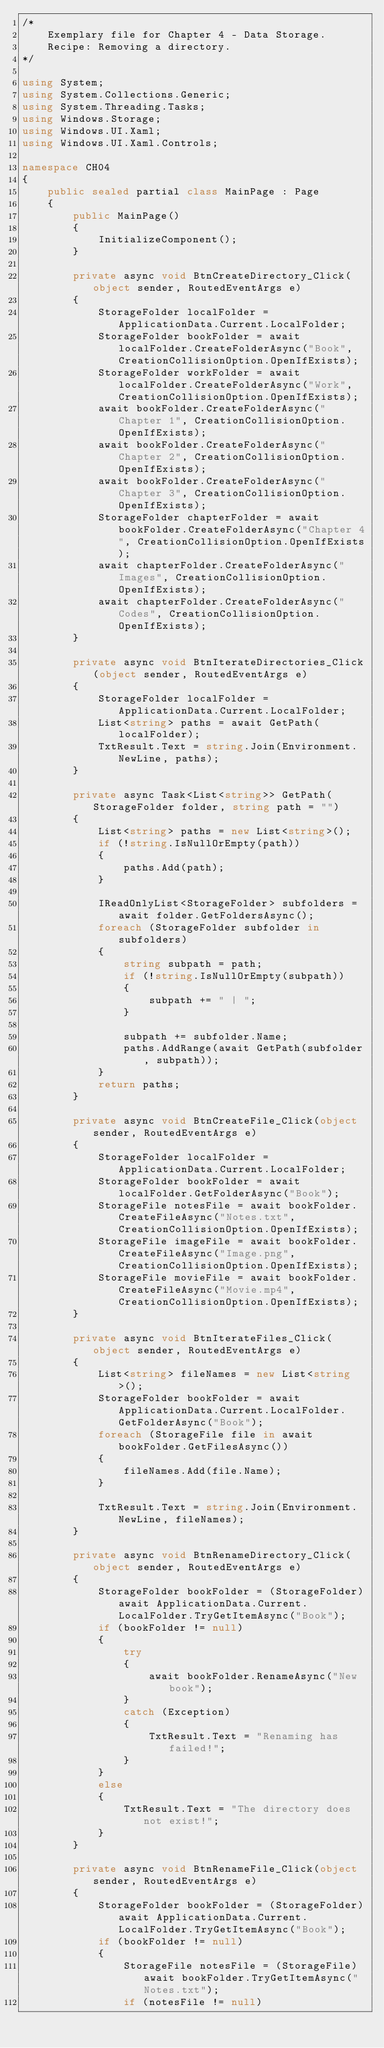<code> <loc_0><loc_0><loc_500><loc_500><_C#_>/*
    Exemplary file for Chapter 4 - Data Storage.
    Recipe: Removing a directory.
*/

using System;
using System.Collections.Generic;
using System.Threading.Tasks;
using Windows.Storage;
using Windows.UI.Xaml;
using Windows.UI.Xaml.Controls;

namespace CH04
{
    public sealed partial class MainPage : Page
    {
        public MainPage()
        {
            InitializeComponent();
        }

        private async void BtnCreateDirectory_Click(object sender, RoutedEventArgs e)
        {
            StorageFolder localFolder = ApplicationData.Current.LocalFolder;
            StorageFolder bookFolder = await localFolder.CreateFolderAsync("Book", CreationCollisionOption.OpenIfExists);
            StorageFolder workFolder = await localFolder.CreateFolderAsync("Work", CreationCollisionOption.OpenIfExists);
            await bookFolder.CreateFolderAsync("Chapter 1", CreationCollisionOption.OpenIfExists);
            await bookFolder.CreateFolderAsync("Chapter 2", CreationCollisionOption.OpenIfExists);
            await bookFolder.CreateFolderAsync("Chapter 3", CreationCollisionOption.OpenIfExists);
            StorageFolder chapterFolder = await bookFolder.CreateFolderAsync("Chapter 4", CreationCollisionOption.OpenIfExists);
            await chapterFolder.CreateFolderAsync("Images", CreationCollisionOption.OpenIfExists);
            await chapterFolder.CreateFolderAsync("Codes", CreationCollisionOption.OpenIfExists);
        }

        private async void BtnIterateDirectories_Click(object sender, RoutedEventArgs e)
        {
            StorageFolder localFolder = ApplicationData.Current.LocalFolder;
            List<string> paths = await GetPath(localFolder);
            TxtResult.Text = string.Join(Environment.NewLine, paths);
        }

        private async Task<List<string>> GetPath(StorageFolder folder, string path = "")
        {
            List<string> paths = new List<string>();
            if (!string.IsNullOrEmpty(path))
            {
                paths.Add(path);
            }

            IReadOnlyList<StorageFolder> subfolders = await folder.GetFoldersAsync();
            foreach (StorageFolder subfolder in subfolders)
            {
                string subpath = path;
                if (!string.IsNullOrEmpty(subpath))
                {
                    subpath += " | ";
                }

                subpath += subfolder.Name;
                paths.AddRange(await GetPath(subfolder, subpath));
            }
            return paths;
        }

        private async void BtnCreateFile_Click(object sender, RoutedEventArgs e)
        {
            StorageFolder localFolder = ApplicationData.Current.LocalFolder;
            StorageFolder bookFolder = await localFolder.GetFolderAsync("Book");
            StorageFile notesFile = await bookFolder.CreateFileAsync("Notes.txt", CreationCollisionOption.OpenIfExists);
            StorageFile imageFile = await bookFolder.CreateFileAsync("Image.png", CreationCollisionOption.OpenIfExists);
            StorageFile movieFile = await bookFolder.CreateFileAsync("Movie.mp4", CreationCollisionOption.OpenIfExists);
        }

        private async void BtnIterateFiles_Click(object sender, RoutedEventArgs e)
        {
            List<string> fileNames = new List<string>();
            StorageFolder bookFolder = await ApplicationData.Current.LocalFolder.GetFolderAsync("Book");
            foreach (StorageFile file in await bookFolder.GetFilesAsync())
            {
                fileNames.Add(file.Name);
            }

            TxtResult.Text = string.Join(Environment.NewLine, fileNames);
        }

        private async void BtnRenameDirectory_Click(object sender, RoutedEventArgs e)
        {
            StorageFolder bookFolder = (StorageFolder)await ApplicationData.Current.LocalFolder.TryGetItemAsync("Book");
            if (bookFolder != null)
            {
                try
                {
                    await bookFolder.RenameAsync("New book");
                }
                catch (Exception)
                {
                    TxtResult.Text = "Renaming has failed!";
                }
            }
            else
            {
                TxtResult.Text = "The directory does not exist!";
            }
        }

        private async void BtnRenameFile_Click(object sender, RoutedEventArgs e)
        {
            StorageFolder bookFolder = (StorageFolder)await ApplicationData.Current.LocalFolder.TryGetItemAsync("Book");
            if (bookFolder != null)
            {
                StorageFile notesFile = (StorageFile)await bookFolder.TryGetItemAsync("Notes.txt");
                if (notesFile != null)</code> 